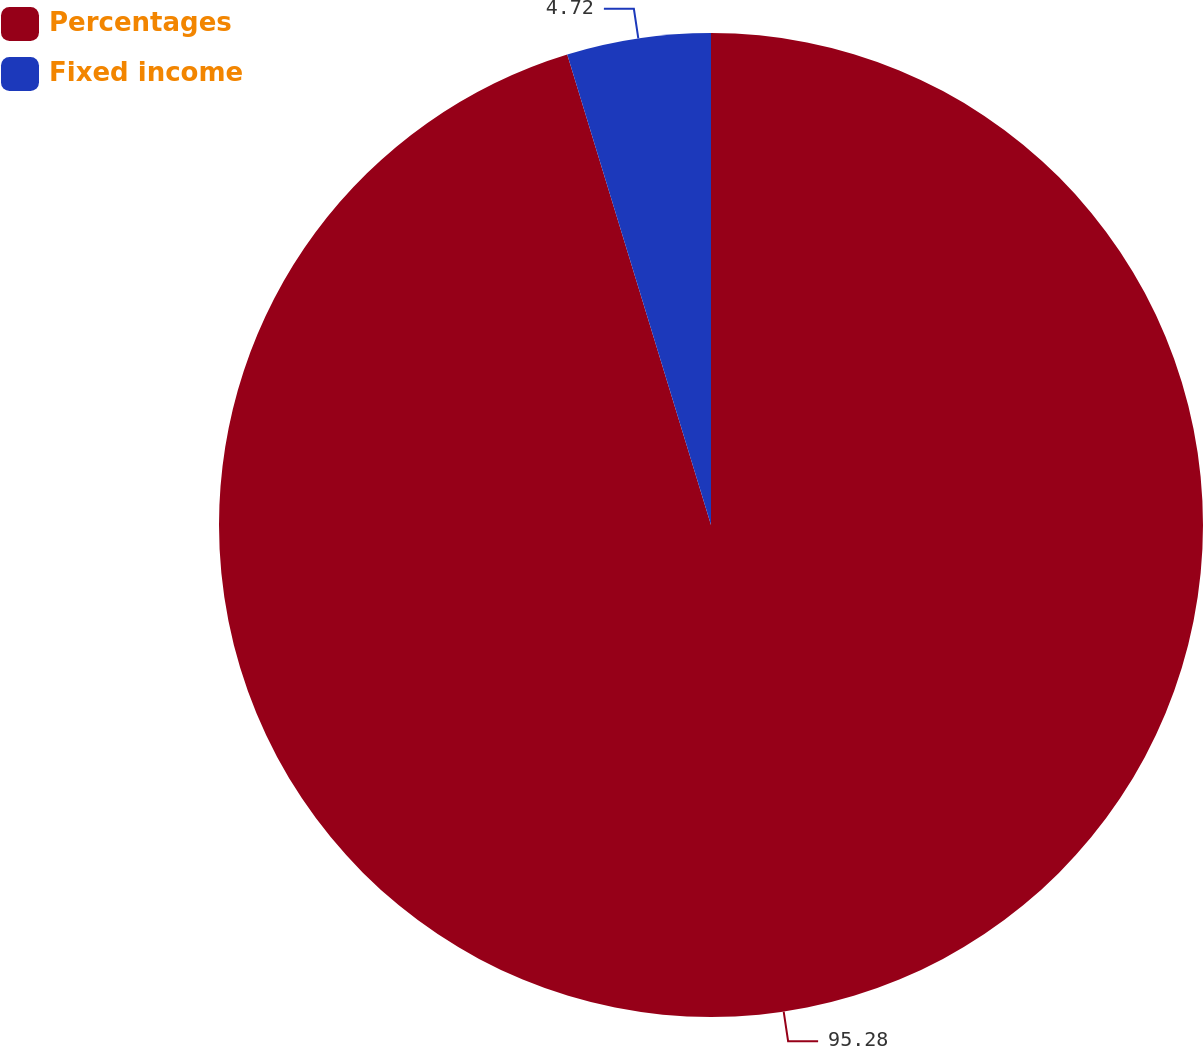Convert chart. <chart><loc_0><loc_0><loc_500><loc_500><pie_chart><fcel>Percentages<fcel>Fixed income<nl><fcel>95.28%<fcel>4.72%<nl></chart> 